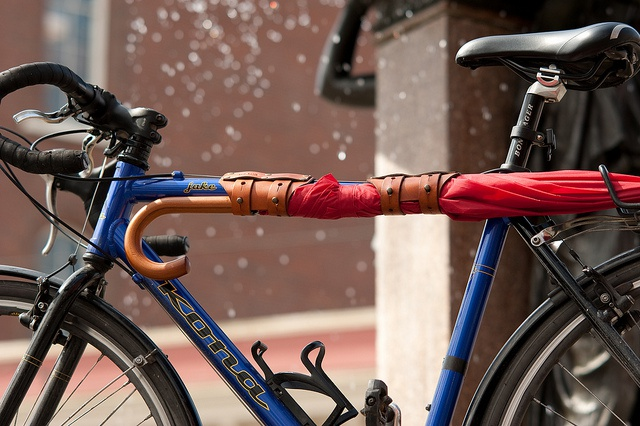Describe the objects in this image and their specific colors. I can see bicycle in brown, black, gray, and ivory tones and umbrella in brown, maroon, and salmon tones in this image. 